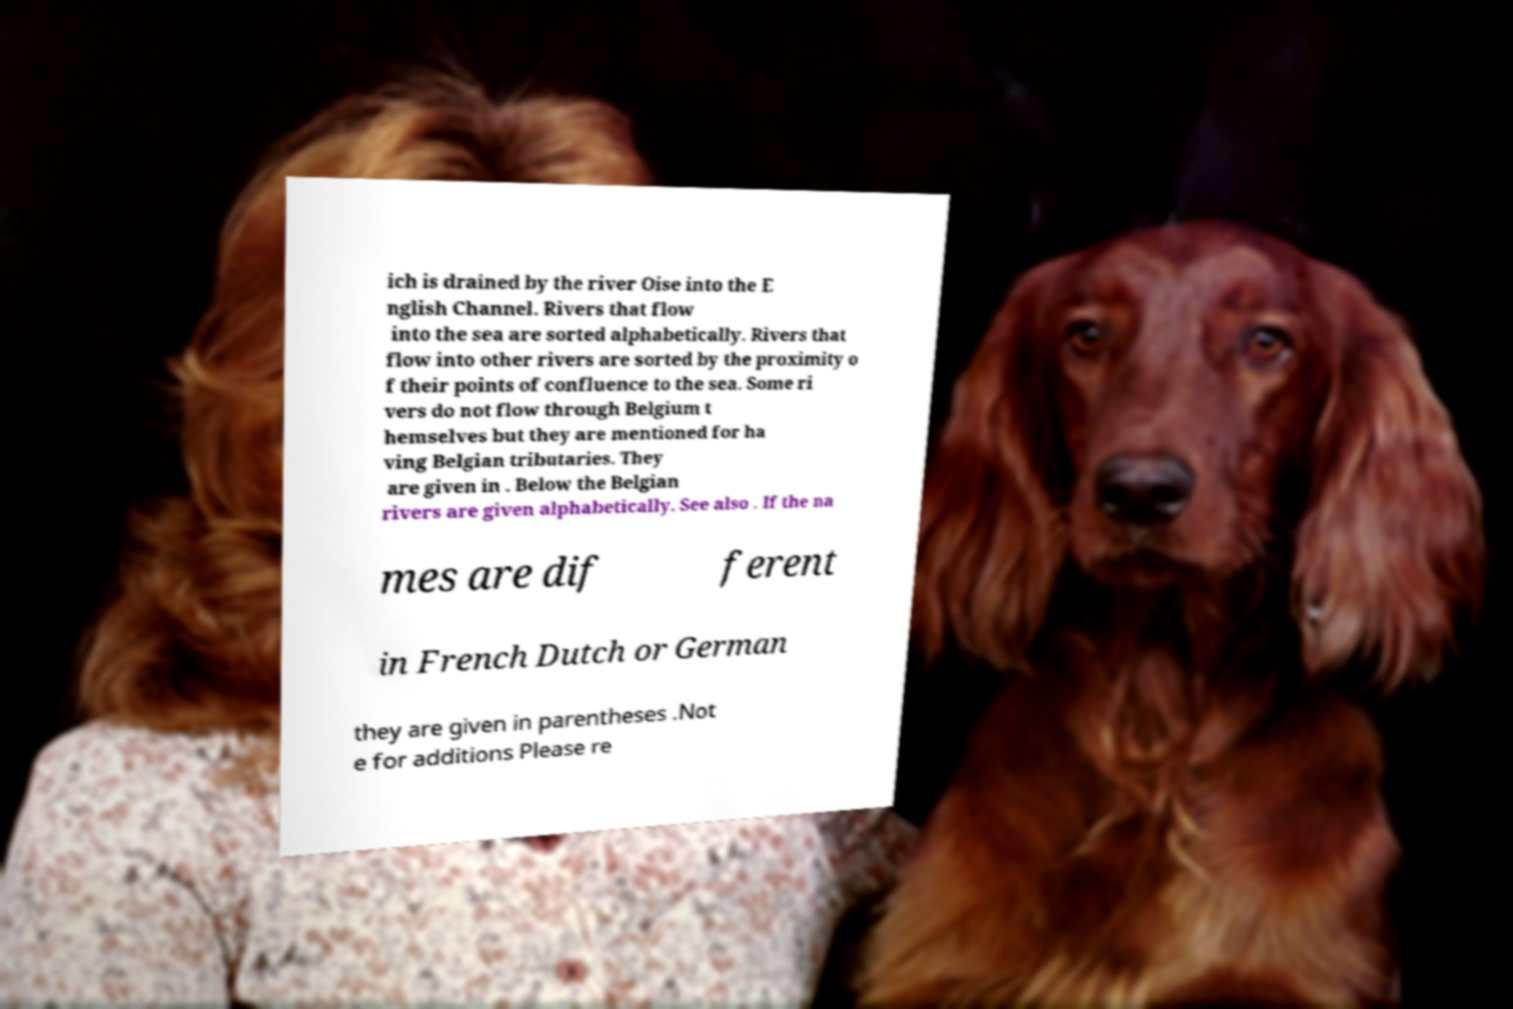For documentation purposes, I need the text within this image transcribed. Could you provide that? ich is drained by the river Oise into the E nglish Channel. Rivers that flow into the sea are sorted alphabetically. Rivers that flow into other rivers are sorted by the proximity o f their points of confluence to the sea. Some ri vers do not flow through Belgium t hemselves but they are mentioned for ha ving Belgian tributaries. They are given in . Below the Belgian rivers are given alphabetically. See also . If the na mes are dif ferent in French Dutch or German they are given in parentheses .Not e for additions Please re 